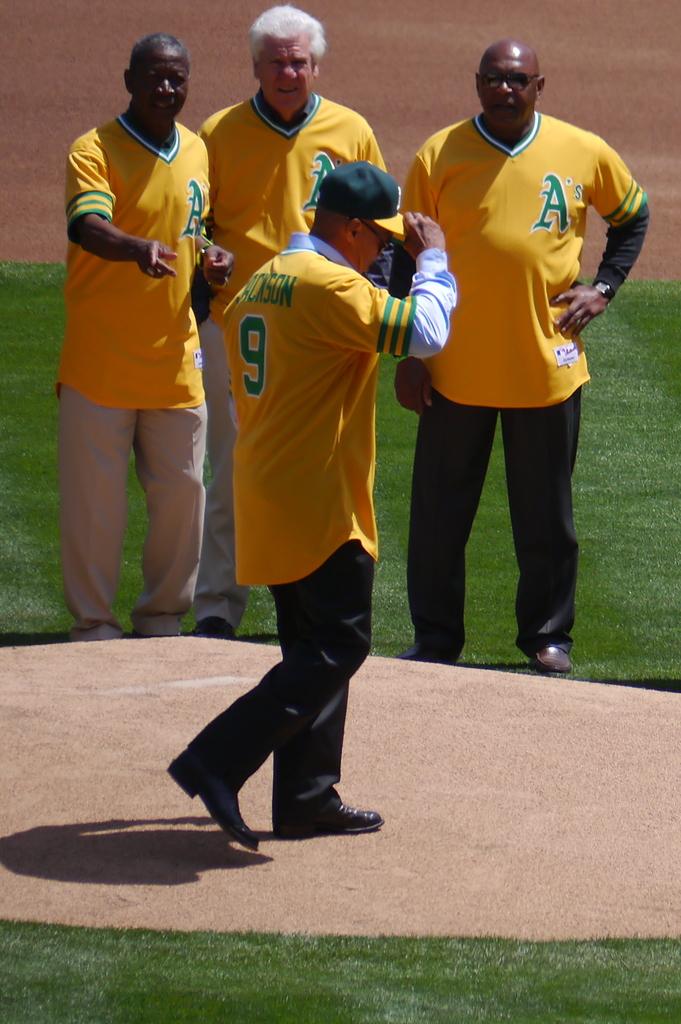What is the name of the baseball team?
Your answer should be very brief. A's. What is the number on the jersey of the guy walking away?
Provide a succinct answer. 9. 